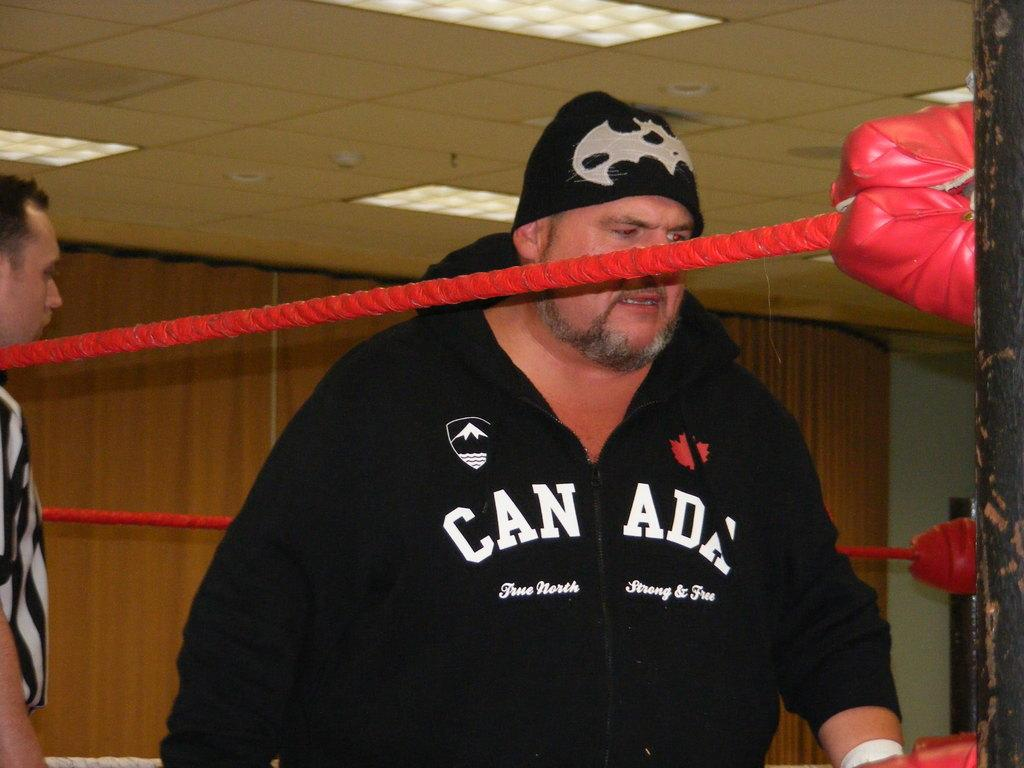<image>
Give a short and clear explanation of the subsequent image. a man that is wearing a Canada sweater 